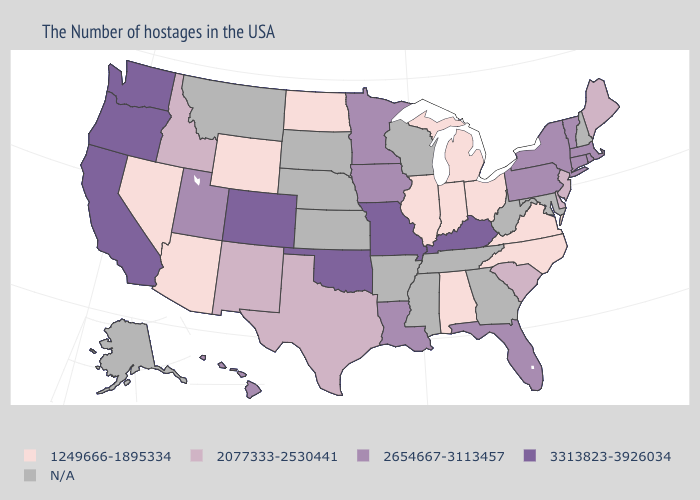Among the states that border Montana , which have the highest value?
Give a very brief answer. Idaho. Name the states that have a value in the range N/A?
Quick response, please. New Hampshire, Maryland, West Virginia, Georgia, Tennessee, Wisconsin, Mississippi, Arkansas, Kansas, Nebraska, South Dakota, Montana, Alaska. Name the states that have a value in the range 3313823-3926034?
Answer briefly. Kentucky, Missouri, Oklahoma, Colorado, California, Washington, Oregon. Is the legend a continuous bar?
Write a very short answer. No. Which states have the lowest value in the USA?
Short answer required. Virginia, North Carolina, Ohio, Michigan, Indiana, Alabama, Illinois, North Dakota, Wyoming, Arizona, Nevada. Among the states that border Ohio , which have the highest value?
Quick response, please. Kentucky. What is the value of South Dakota?
Quick response, please. N/A. What is the value of Kansas?
Write a very short answer. N/A. Name the states that have a value in the range 2654667-3113457?
Quick response, please. Massachusetts, Rhode Island, Vermont, Connecticut, New York, Pennsylvania, Florida, Louisiana, Minnesota, Iowa, Utah, Hawaii. What is the lowest value in the USA?
Quick response, please. 1249666-1895334. Name the states that have a value in the range 1249666-1895334?
Short answer required. Virginia, North Carolina, Ohio, Michigan, Indiana, Alabama, Illinois, North Dakota, Wyoming, Arizona, Nevada. Is the legend a continuous bar?
Keep it brief. No. Among the states that border Idaho , which have the highest value?
Answer briefly. Washington, Oregon. 